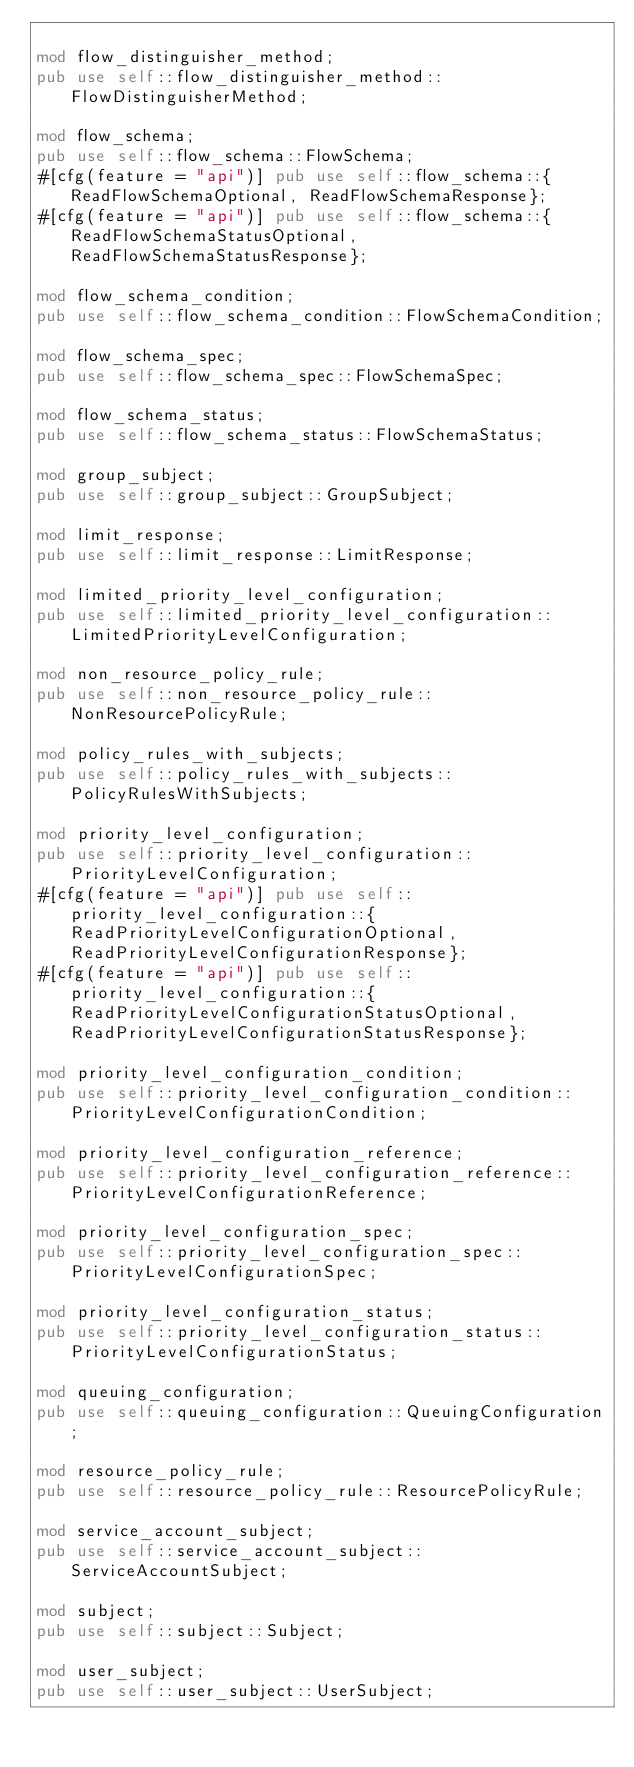<code> <loc_0><loc_0><loc_500><loc_500><_Rust_>
mod flow_distinguisher_method;
pub use self::flow_distinguisher_method::FlowDistinguisherMethod;

mod flow_schema;
pub use self::flow_schema::FlowSchema;
#[cfg(feature = "api")] pub use self::flow_schema::{ReadFlowSchemaOptional, ReadFlowSchemaResponse};
#[cfg(feature = "api")] pub use self::flow_schema::{ReadFlowSchemaStatusOptional, ReadFlowSchemaStatusResponse};

mod flow_schema_condition;
pub use self::flow_schema_condition::FlowSchemaCondition;

mod flow_schema_spec;
pub use self::flow_schema_spec::FlowSchemaSpec;

mod flow_schema_status;
pub use self::flow_schema_status::FlowSchemaStatus;

mod group_subject;
pub use self::group_subject::GroupSubject;

mod limit_response;
pub use self::limit_response::LimitResponse;

mod limited_priority_level_configuration;
pub use self::limited_priority_level_configuration::LimitedPriorityLevelConfiguration;

mod non_resource_policy_rule;
pub use self::non_resource_policy_rule::NonResourcePolicyRule;

mod policy_rules_with_subjects;
pub use self::policy_rules_with_subjects::PolicyRulesWithSubjects;

mod priority_level_configuration;
pub use self::priority_level_configuration::PriorityLevelConfiguration;
#[cfg(feature = "api")] pub use self::priority_level_configuration::{ReadPriorityLevelConfigurationOptional, ReadPriorityLevelConfigurationResponse};
#[cfg(feature = "api")] pub use self::priority_level_configuration::{ReadPriorityLevelConfigurationStatusOptional, ReadPriorityLevelConfigurationStatusResponse};

mod priority_level_configuration_condition;
pub use self::priority_level_configuration_condition::PriorityLevelConfigurationCondition;

mod priority_level_configuration_reference;
pub use self::priority_level_configuration_reference::PriorityLevelConfigurationReference;

mod priority_level_configuration_spec;
pub use self::priority_level_configuration_spec::PriorityLevelConfigurationSpec;

mod priority_level_configuration_status;
pub use self::priority_level_configuration_status::PriorityLevelConfigurationStatus;

mod queuing_configuration;
pub use self::queuing_configuration::QueuingConfiguration;

mod resource_policy_rule;
pub use self::resource_policy_rule::ResourcePolicyRule;

mod service_account_subject;
pub use self::service_account_subject::ServiceAccountSubject;

mod subject;
pub use self::subject::Subject;

mod user_subject;
pub use self::user_subject::UserSubject;
</code> 